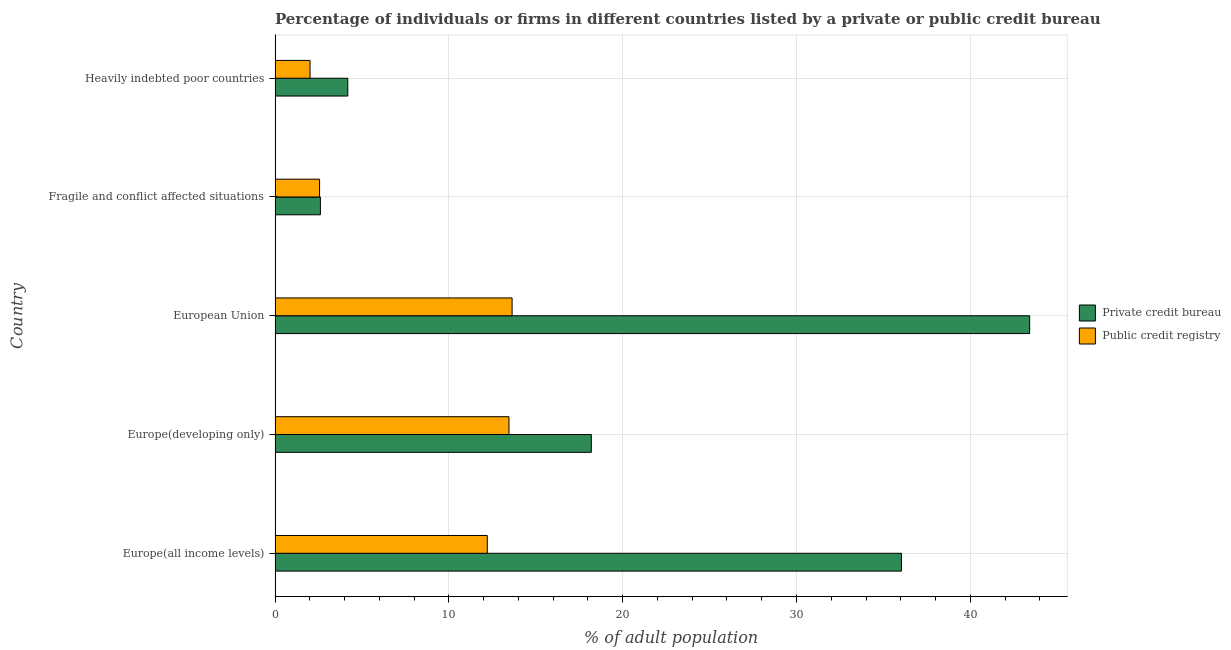How many different coloured bars are there?
Offer a very short reply. 2. How many groups of bars are there?
Make the answer very short. 5. Are the number of bars per tick equal to the number of legend labels?
Your response must be concise. Yes. How many bars are there on the 2nd tick from the top?
Provide a succinct answer. 2. How many bars are there on the 5th tick from the bottom?
Keep it short and to the point. 2. What is the label of the 1st group of bars from the top?
Your response must be concise. Heavily indebted poor countries. In how many cases, is the number of bars for a given country not equal to the number of legend labels?
Your answer should be compact. 0. What is the percentage of firms listed by private credit bureau in European Union?
Provide a short and direct response. 43.41. Across all countries, what is the maximum percentage of firms listed by private credit bureau?
Keep it short and to the point. 43.41. Across all countries, what is the minimum percentage of firms listed by private credit bureau?
Ensure brevity in your answer.  2.61. In which country was the percentage of firms listed by public credit bureau maximum?
Provide a short and direct response. European Union. In which country was the percentage of firms listed by private credit bureau minimum?
Your answer should be compact. Fragile and conflict affected situations. What is the total percentage of firms listed by private credit bureau in the graph?
Ensure brevity in your answer.  104.44. What is the difference between the percentage of firms listed by private credit bureau in Europe(all income levels) and that in Heavily indebted poor countries?
Offer a terse response. 31.85. What is the difference between the percentage of firms listed by public credit bureau in Europe(all income levels) and the percentage of firms listed by private credit bureau in Fragile and conflict affected situations?
Keep it short and to the point. 9.6. What is the average percentage of firms listed by public credit bureau per country?
Keep it short and to the point. 8.78. What is the difference between the percentage of firms listed by public credit bureau and percentage of firms listed by private credit bureau in European Union?
Offer a terse response. -29.78. What is the ratio of the percentage of firms listed by private credit bureau in Europe(all income levels) to that in Fragile and conflict affected situations?
Make the answer very short. 13.82. What is the difference between the highest and the second highest percentage of firms listed by private credit bureau?
Offer a terse response. 7.38. What is the difference between the highest and the lowest percentage of firms listed by private credit bureau?
Offer a very short reply. 40.81. In how many countries, is the percentage of firms listed by public credit bureau greater than the average percentage of firms listed by public credit bureau taken over all countries?
Provide a short and direct response. 3. What does the 2nd bar from the top in Europe(developing only) represents?
Keep it short and to the point. Private credit bureau. What does the 1st bar from the bottom in Europe(all income levels) represents?
Your response must be concise. Private credit bureau. Are the values on the major ticks of X-axis written in scientific E-notation?
Give a very brief answer. No. Does the graph contain any zero values?
Your response must be concise. No. How are the legend labels stacked?
Your answer should be compact. Vertical. What is the title of the graph?
Provide a succinct answer. Percentage of individuals or firms in different countries listed by a private or public credit bureau. Does "Study and work" appear as one of the legend labels in the graph?
Ensure brevity in your answer.  No. What is the label or title of the X-axis?
Offer a terse response. % of adult population. What is the label or title of the Y-axis?
Provide a succinct answer. Country. What is the % of adult population of Private credit bureau in Europe(all income levels)?
Offer a very short reply. 36.04. What is the % of adult population in Public credit registry in Europe(all income levels)?
Provide a succinct answer. 12.21. What is the % of adult population in Private credit bureau in Europe(developing only)?
Offer a terse response. 18.19. What is the % of adult population of Public credit registry in Europe(developing only)?
Give a very brief answer. 13.46. What is the % of adult population of Private credit bureau in European Union?
Provide a short and direct response. 43.41. What is the % of adult population of Public credit registry in European Union?
Offer a very short reply. 13.64. What is the % of adult population in Private credit bureau in Fragile and conflict affected situations?
Provide a short and direct response. 2.61. What is the % of adult population in Public credit registry in Fragile and conflict affected situations?
Provide a succinct answer. 2.56. What is the % of adult population in Private credit bureau in Heavily indebted poor countries?
Provide a succinct answer. 4.18. What is the % of adult population of Public credit registry in Heavily indebted poor countries?
Give a very brief answer. 2.01. Across all countries, what is the maximum % of adult population in Private credit bureau?
Your answer should be compact. 43.41. Across all countries, what is the maximum % of adult population in Public credit registry?
Offer a very short reply. 13.64. Across all countries, what is the minimum % of adult population of Private credit bureau?
Make the answer very short. 2.61. Across all countries, what is the minimum % of adult population in Public credit registry?
Provide a succinct answer. 2.01. What is the total % of adult population in Private credit bureau in the graph?
Your response must be concise. 104.44. What is the total % of adult population of Public credit registry in the graph?
Give a very brief answer. 43.88. What is the difference between the % of adult population of Private credit bureau in Europe(all income levels) and that in Europe(developing only)?
Give a very brief answer. 17.84. What is the difference between the % of adult population in Public credit registry in Europe(all income levels) and that in Europe(developing only)?
Offer a terse response. -1.25. What is the difference between the % of adult population in Private credit bureau in Europe(all income levels) and that in European Union?
Provide a short and direct response. -7.38. What is the difference between the % of adult population of Public credit registry in Europe(all income levels) and that in European Union?
Keep it short and to the point. -1.43. What is the difference between the % of adult population of Private credit bureau in Europe(all income levels) and that in Fragile and conflict affected situations?
Provide a short and direct response. 33.43. What is the difference between the % of adult population in Public credit registry in Europe(all income levels) and that in Fragile and conflict affected situations?
Give a very brief answer. 9.65. What is the difference between the % of adult population in Private credit bureau in Europe(all income levels) and that in Heavily indebted poor countries?
Give a very brief answer. 31.85. What is the difference between the % of adult population in Public credit registry in Europe(all income levels) and that in Heavily indebted poor countries?
Your response must be concise. 10.2. What is the difference between the % of adult population in Private credit bureau in Europe(developing only) and that in European Union?
Your response must be concise. -25.22. What is the difference between the % of adult population of Public credit registry in Europe(developing only) and that in European Union?
Give a very brief answer. -0.18. What is the difference between the % of adult population in Private credit bureau in Europe(developing only) and that in Fragile and conflict affected situations?
Offer a very short reply. 15.59. What is the difference between the % of adult population of Public credit registry in Europe(developing only) and that in Fragile and conflict affected situations?
Give a very brief answer. 10.9. What is the difference between the % of adult population of Private credit bureau in Europe(developing only) and that in Heavily indebted poor countries?
Ensure brevity in your answer.  14.01. What is the difference between the % of adult population of Public credit registry in Europe(developing only) and that in Heavily indebted poor countries?
Make the answer very short. 11.45. What is the difference between the % of adult population in Private credit bureau in European Union and that in Fragile and conflict affected situations?
Keep it short and to the point. 40.81. What is the difference between the % of adult population of Public credit registry in European Union and that in Fragile and conflict affected situations?
Offer a terse response. 11.08. What is the difference between the % of adult population in Private credit bureau in European Union and that in Heavily indebted poor countries?
Keep it short and to the point. 39.23. What is the difference between the % of adult population in Public credit registry in European Union and that in Heavily indebted poor countries?
Your response must be concise. 11.63. What is the difference between the % of adult population in Private credit bureau in Fragile and conflict affected situations and that in Heavily indebted poor countries?
Your response must be concise. -1.58. What is the difference between the % of adult population of Public credit registry in Fragile and conflict affected situations and that in Heavily indebted poor countries?
Offer a very short reply. 0.55. What is the difference between the % of adult population in Private credit bureau in Europe(all income levels) and the % of adult population in Public credit registry in Europe(developing only)?
Make the answer very short. 22.58. What is the difference between the % of adult population in Private credit bureau in Europe(all income levels) and the % of adult population in Public credit registry in European Union?
Offer a terse response. 22.4. What is the difference between the % of adult population of Private credit bureau in Europe(all income levels) and the % of adult population of Public credit registry in Fragile and conflict affected situations?
Offer a very short reply. 33.48. What is the difference between the % of adult population in Private credit bureau in Europe(all income levels) and the % of adult population in Public credit registry in Heavily indebted poor countries?
Keep it short and to the point. 34.03. What is the difference between the % of adult population of Private credit bureau in Europe(developing only) and the % of adult population of Public credit registry in European Union?
Ensure brevity in your answer.  4.56. What is the difference between the % of adult population in Private credit bureau in Europe(developing only) and the % of adult population in Public credit registry in Fragile and conflict affected situations?
Your response must be concise. 15.63. What is the difference between the % of adult population in Private credit bureau in Europe(developing only) and the % of adult population in Public credit registry in Heavily indebted poor countries?
Your answer should be very brief. 16.18. What is the difference between the % of adult population in Private credit bureau in European Union and the % of adult population in Public credit registry in Fragile and conflict affected situations?
Provide a short and direct response. 40.85. What is the difference between the % of adult population of Private credit bureau in European Union and the % of adult population of Public credit registry in Heavily indebted poor countries?
Your answer should be compact. 41.4. What is the difference between the % of adult population of Private credit bureau in Fragile and conflict affected situations and the % of adult population of Public credit registry in Heavily indebted poor countries?
Ensure brevity in your answer.  0.6. What is the average % of adult population of Private credit bureau per country?
Ensure brevity in your answer.  20.89. What is the average % of adult population in Public credit registry per country?
Your answer should be very brief. 8.78. What is the difference between the % of adult population of Private credit bureau and % of adult population of Public credit registry in Europe(all income levels)?
Offer a terse response. 23.83. What is the difference between the % of adult population in Private credit bureau and % of adult population in Public credit registry in Europe(developing only)?
Your response must be concise. 4.74. What is the difference between the % of adult population in Private credit bureau and % of adult population in Public credit registry in European Union?
Ensure brevity in your answer.  29.78. What is the difference between the % of adult population in Private credit bureau and % of adult population in Public credit registry in Fragile and conflict affected situations?
Your answer should be very brief. 0.05. What is the difference between the % of adult population of Private credit bureau and % of adult population of Public credit registry in Heavily indebted poor countries?
Keep it short and to the point. 2.17. What is the ratio of the % of adult population in Private credit bureau in Europe(all income levels) to that in Europe(developing only)?
Provide a short and direct response. 1.98. What is the ratio of the % of adult population in Public credit registry in Europe(all income levels) to that in Europe(developing only)?
Your response must be concise. 0.91. What is the ratio of the % of adult population of Private credit bureau in Europe(all income levels) to that in European Union?
Offer a terse response. 0.83. What is the ratio of the % of adult population of Public credit registry in Europe(all income levels) to that in European Union?
Keep it short and to the point. 0.9. What is the ratio of the % of adult population in Private credit bureau in Europe(all income levels) to that in Fragile and conflict affected situations?
Provide a short and direct response. 13.83. What is the ratio of the % of adult population of Public credit registry in Europe(all income levels) to that in Fragile and conflict affected situations?
Provide a short and direct response. 4.77. What is the ratio of the % of adult population in Private credit bureau in Europe(all income levels) to that in Heavily indebted poor countries?
Provide a succinct answer. 8.61. What is the ratio of the % of adult population in Public credit registry in Europe(all income levels) to that in Heavily indebted poor countries?
Offer a very short reply. 6.07. What is the ratio of the % of adult population of Private credit bureau in Europe(developing only) to that in European Union?
Your response must be concise. 0.42. What is the ratio of the % of adult population in Public credit registry in Europe(developing only) to that in European Union?
Make the answer very short. 0.99. What is the ratio of the % of adult population of Private credit bureau in Europe(developing only) to that in Fragile and conflict affected situations?
Your response must be concise. 6.98. What is the ratio of the % of adult population of Public credit registry in Europe(developing only) to that in Fragile and conflict affected situations?
Offer a very short reply. 5.26. What is the ratio of the % of adult population in Private credit bureau in Europe(developing only) to that in Heavily indebted poor countries?
Offer a terse response. 4.35. What is the ratio of the % of adult population in Public credit registry in Europe(developing only) to that in Heavily indebted poor countries?
Your answer should be compact. 6.69. What is the ratio of the % of adult population in Private credit bureau in European Union to that in Fragile and conflict affected situations?
Provide a short and direct response. 16.66. What is the ratio of the % of adult population of Public credit registry in European Union to that in Fragile and conflict affected situations?
Make the answer very short. 5.33. What is the ratio of the % of adult population of Private credit bureau in European Union to that in Heavily indebted poor countries?
Keep it short and to the point. 10.38. What is the ratio of the % of adult population in Public credit registry in European Union to that in Heavily indebted poor countries?
Make the answer very short. 6.78. What is the ratio of the % of adult population in Private credit bureau in Fragile and conflict affected situations to that in Heavily indebted poor countries?
Your answer should be compact. 0.62. What is the ratio of the % of adult population of Public credit registry in Fragile and conflict affected situations to that in Heavily indebted poor countries?
Ensure brevity in your answer.  1.27. What is the difference between the highest and the second highest % of adult population in Private credit bureau?
Your answer should be very brief. 7.38. What is the difference between the highest and the second highest % of adult population in Public credit registry?
Provide a short and direct response. 0.18. What is the difference between the highest and the lowest % of adult population in Private credit bureau?
Ensure brevity in your answer.  40.81. What is the difference between the highest and the lowest % of adult population of Public credit registry?
Offer a terse response. 11.63. 